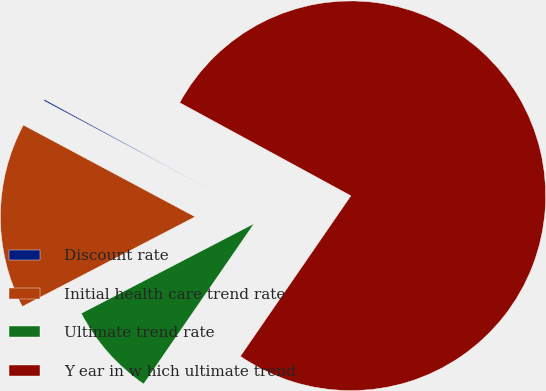Convert chart. <chart><loc_0><loc_0><loc_500><loc_500><pie_chart><fcel>Discount rate<fcel>Initial health care trend rate<fcel>Ultimate trend rate<fcel>Y ear in w hich ultimate trend<nl><fcel>0.12%<fcel>15.43%<fcel>7.78%<fcel>76.67%<nl></chart> 